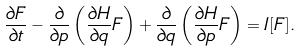Convert formula to latex. <formula><loc_0><loc_0><loc_500><loc_500>\frac { \partial F } { \partial t } - \frac { \partial } { \partial p } \left ( \frac { \partial H } { \partial q } F \right ) + \frac { \partial } { \partial q } \left ( \frac { \partial H } { \partial p } F \right ) = I [ F ] .</formula> 